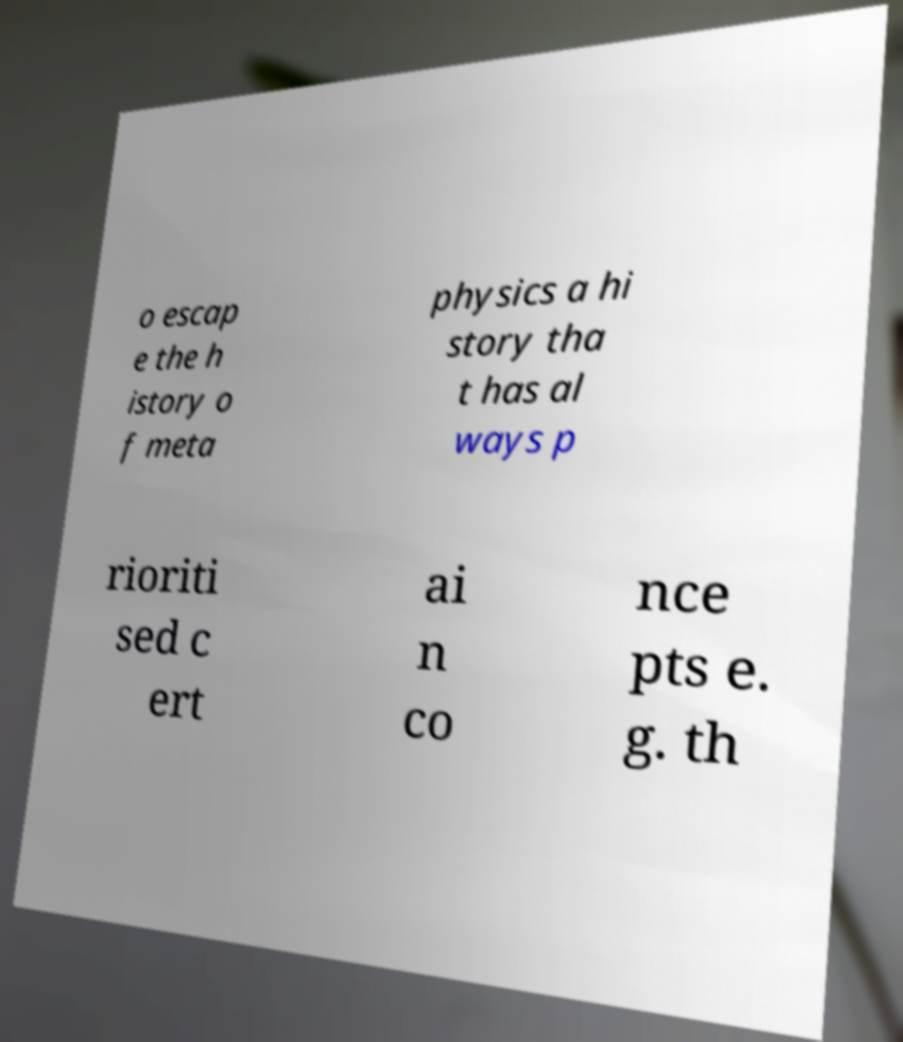There's text embedded in this image that I need extracted. Can you transcribe it verbatim? o escap e the h istory o f meta physics a hi story tha t has al ways p rioriti sed c ert ai n co nce pts e. g. th 